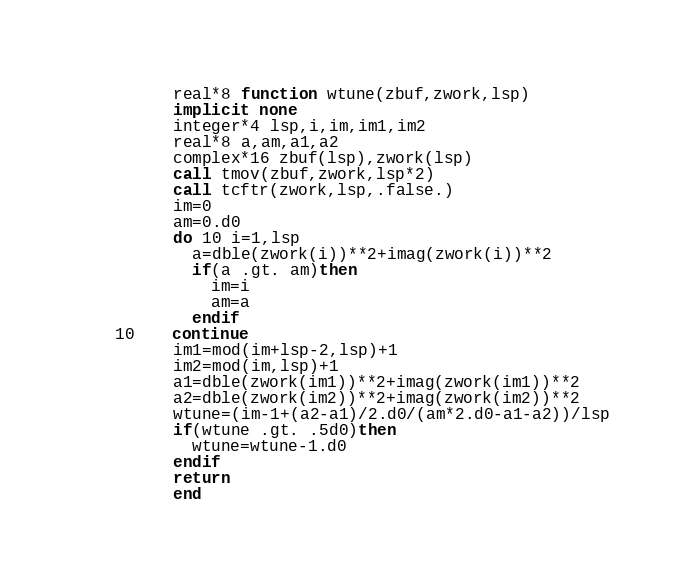<code> <loc_0><loc_0><loc_500><loc_500><_FORTRAN_>      real*8 function wtune(zbuf,zwork,lsp)
      implicit none
      integer*4 lsp,i,im,im1,im2
      real*8 a,am,a1,a2
      complex*16 zbuf(lsp),zwork(lsp)
      call tmov(zbuf,zwork,lsp*2)
      call tcftr(zwork,lsp,.false.)
      im=0
      am=0.d0
      do 10 i=1,lsp
        a=dble(zwork(i))**2+imag(zwork(i))**2
        if(a .gt. am)then
          im=i
          am=a
        endif
10    continue
      im1=mod(im+lsp-2,lsp)+1
      im2=mod(im,lsp)+1
      a1=dble(zwork(im1))**2+imag(zwork(im1))**2
      a2=dble(zwork(im2))**2+imag(zwork(im2))**2
      wtune=(im-1+(a2-a1)/2.d0/(am*2.d0-a1-a2))/lsp
      if(wtune .gt. .5d0)then
        wtune=wtune-1.d0
      endif
      return
      end
</code> 